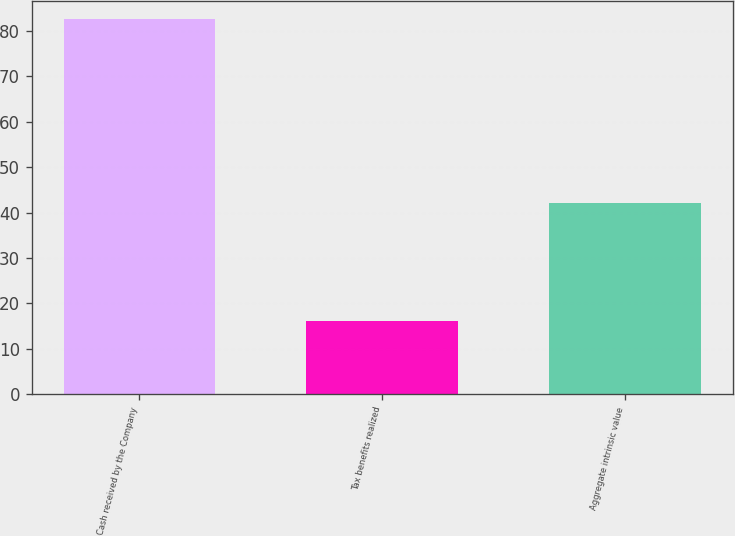<chart> <loc_0><loc_0><loc_500><loc_500><bar_chart><fcel>Cash received by the Company<fcel>Tax benefits realized<fcel>Aggregate intrinsic value<nl><fcel>82.6<fcel>16.2<fcel>42.2<nl></chart> 